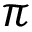<formula> <loc_0><loc_0><loc_500><loc_500>\pi</formula> 